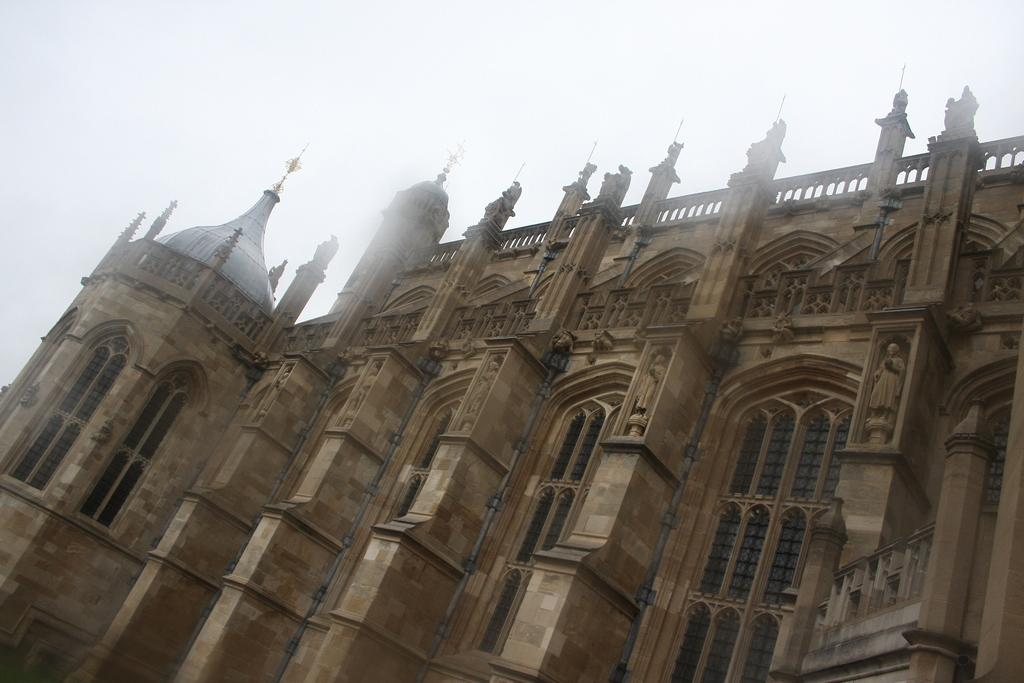What type of building is in the picture? There is a historic church building in the picture. What colors can be seen on the church building? The church building is brown and black in color. What religious symbol is on top of the church building? There is a cross on top of the church building. What can be seen in the background of the picture? The sky is visible in the background of the picture. What type of breakfast is being served in the picture? There is no breakfast visible in the picture; it features a historic church building. What word is written on the side of the church building? There is no word visible on the church building in the image. 